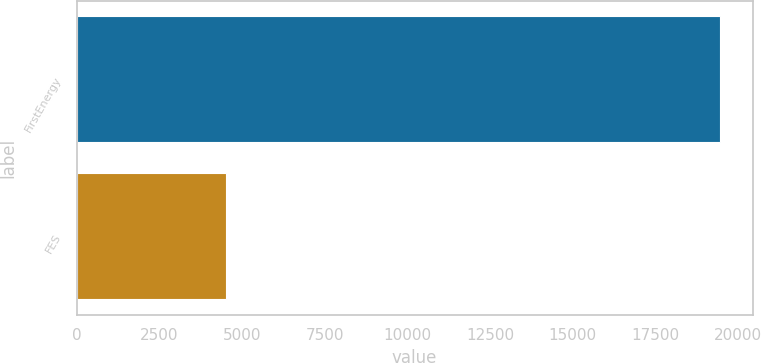<chart> <loc_0><loc_0><loc_500><loc_500><bar_chart><fcel>FirstEnergy<fcel>FES<nl><fcel>19460<fcel>4524<nl></chart> 